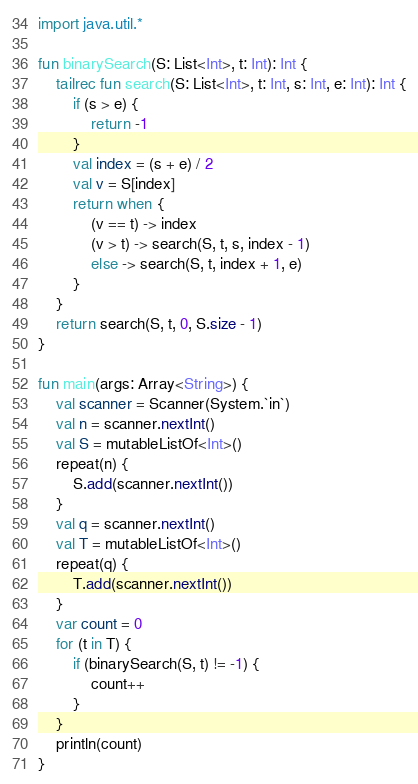<code> <loc_0><loc_0><loc_500><loc_500><_Kotlin_>import java.util.*

fun binarySearch(S: List<Int>, t: Int): Int {
    tailrec fun search(S: List<Int>, t: Int, s: Int, e: Int): Int {
        if (s > e) {
            return -1
        }
        val index = (s + e) / 2
        val v = S[index]
        return when {
            (v == t) -> index
            (v > t) -> search(S, t, s, index - 1)
            else -> search(S, t, index + 1, e)
        }
    }
    return search(S, t, 0, S.size - 1)
}

fun main(args: Array<String>) {
    val scanner = Scanner(System.`in`)
    val n = scanner.nextInt()
    val S = mutableListOf<Int>()
    repeat(n) {
        S.add(scanner.nextInt())
    }
    val q = scanner.nextInt()
    val T = mutableListOf<Int>()
    repeat(q) {
        T.add(scanner.nextInt())
    }
    var count = 0
    for (t in T) {
        if (binarySearch(S, t) != -1) {
            count++
        }
    }
    println(count)
}

</code> 